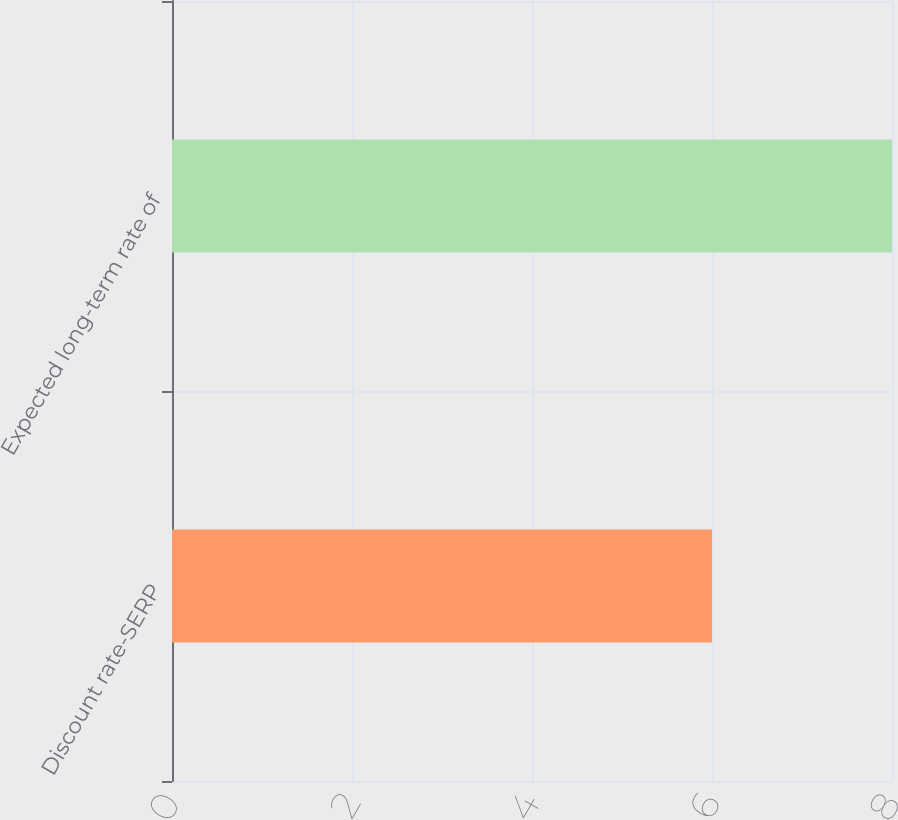<chart> <loc_0><loc_0><loc_500><loc_500><bar_chart><fcel>Discount rate-SERP<fcel>Expected long-term rate of<nl><fcel>6<fcel>8<nl></chart> 